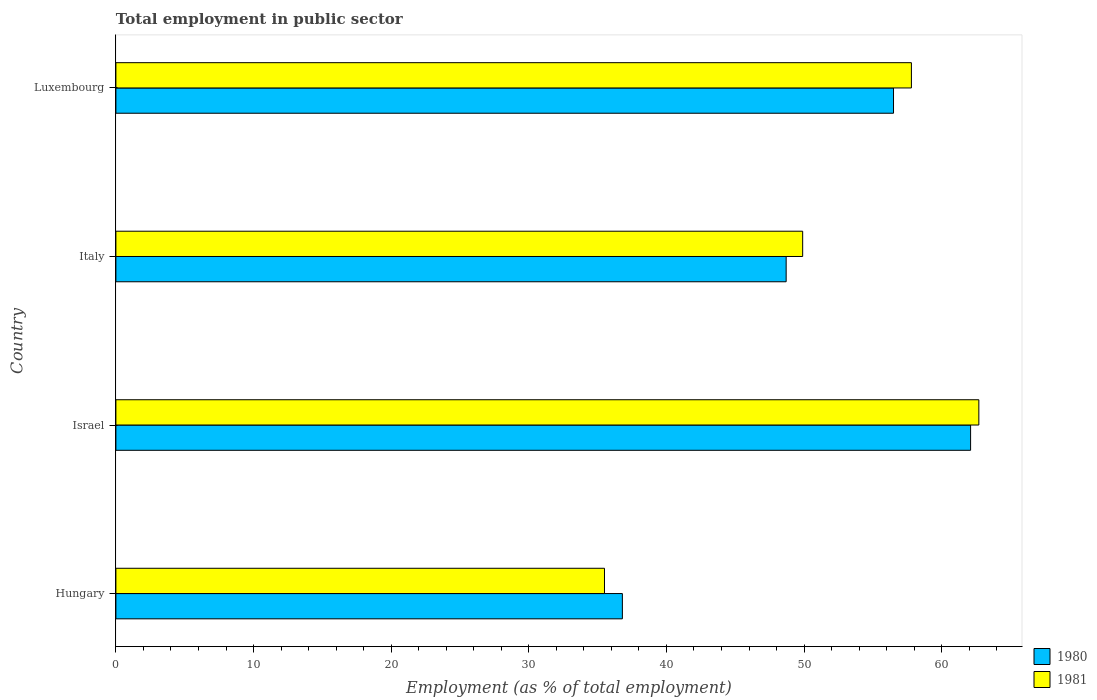How many groups of bars are there?
Provide a succinct answer. 4. Are the number of bars per tick equal to the number of legend labels?
Provide a succinct answer. Yes. Are the number of bars on each tick of the Y-axis equal?
Offer a very short reply. Yes. What is the label of the 3rd group of bars from the top?
Offer a terse response. Israel. In how many cases, is the number of bars for a given country not equal to the number of legend labels?
Your response must be concise. 0. What is the employment in public sector in 1980 in Israel?
Keep it short and to the point. 62.1. Across all countries, what is the maximum employment in public sector in 1981?
Provide a short and direct response. 62.7. Across all countries, what is the minimum employment in public sector in 1980?
Your answer should be compact. 36.8. In which country was the employment in public sector in 1981 maximum?
Your answer should be compact. Israel. In which country was the employment in public sector in 1981 minimum?
Your answer should be very brief. Hungary. What is the total employment in public sector in 1980 in the graph?
Provide a succinct answer. 204.1. What is the difference between the employment in public sector in 1981 in Hungary and that in Luxembourg?
Make the answer very short. -22.3. What is the difference between the employment in public sector in 1980 in Luxembourg and the employment in public sector in 1981 in Italy?
Provide a short and direct response. 6.6. What is the average employment in public sector in 1980 per country?
Your answer should be compact. 51.02. What is the difference between the employment in public sector in 1981 and employment in public sector in 1980 in Luxembourg?
Ensure brevity in your answer.  1.3. In how many countries, is the employment in public sector in 1980 greater than 22 %?
Offer a very short reply. 4. What is the ratio of the employment in public sector in 1980 in Hungary to that in Luxembourg?
Your answer should be very brief. 0.65. Is the employment in public sector in 1981 in Hungary less than that in Israel?
Give a very brief answer. Yes. What is the difference between the highest and the second highest employment in public sector in 1981?
Offer a very short reply. 4.9. What is the difference between the highest and the lowest employment in public sector in 1981?
Offer a terse response. 27.2. Are all the bars in the graph horizontal?
Your response must be concise. Yes. How many countries are there in the graph?
Provide a succinct answer. 4. Does the graph contain grids?
Your response must be concise. No. How many legend labels are there?
Provide a succinct answer. 2. How are the legend labels stacked?
Your answer should be very brief. Vertical. What is the title of the graph?
Your response must be concise. Total employment in public sector. What is the label or title of the X-axis?
Provide a short and direct response. Employment (as % of total employment). What is the label or title of the Y-axis?
Ensure brevity in your answer.  Country. What is the Employment (as % of total employment) of 1980 in Hungary?
Your response must be concise. 36.8. What is the Employment (as % of total employment) in 1981 in Hungary?
Provide a short and direct response. 35.5. What is the Employment (as % of total employment) in 1980 in Israel?
Keep it short and to the point. 62.1. What is the Employment (as % of total employment) in 1981 in Israel?
Keep it short and to the point. 62.7. What is the Employment (as % of total employment) of 1980 in Italy?
Your answer should be very brief. 48.7. What is the Employment (as % of total employment) of 1981 in Italy?
Provide a short and direct response. 49.9. What is the Employment (as % of total employment) of 1980 in Luxembourg?
Ensure brevity in your answer.  56.5. What is the Employment (as % of total employment) in 1981 in Luxembourg?
Ensure brevity in your answer.  57.8. Across all countries, what is the maximum Employment (as % of total employment) in 1980?
Make the answer very short. 62.1. Across all countries, what is the maximum Employment (as % of total employment) in 1981?
Offer a very short reply. 62.7. Across all countries, what is the minimum Employment (as % of total employment) of 1980?
Keep it short and to the point. 36.8. Across all countries, what is the minimum Employment (as % of total employment) in 1981?
Your answer should be compact. 35.5. What is the total Employment (as % of total employment) of 1980 in the graph?
Make the answer very short. 204.1. What is the total Employment (as % of total employment) of 1981 in the graph?
Keep it short and to the point. 205.9. What is the difference between the Employment (as % of total employment) of 1980 in Hungary and that in Israel?
Your response must be concise. -25.3. What is the difference between the Employment (as % of total employment) in 1981 in Hungary and that in Israel?
Offer a terse response. -27.2. What is the difference between the Employment (as % of total employment) in 1980 in Hungary and that in Italy?
Provide a succinct answer. -11.9. What is the difference between the Employment (as % of total employment) in 1981 in Hungary and that in Italy?
Your answer should be compact. -14.4. What is the difference between the Employment (as % of total employment) in 1980 in Hungary and that in Luxembourg?
Keep it short and to the point. -19.7. What is the difference between the Employment (as % of total employment) in 1981 in Hungary and that in Luxembourg?
Provide a succinct answer. -22.3. What is the difference between the Employment (as % of total employment) of 1980 in Israel and that in Italy?
Provide a succinct answer. 13.4. What is the difference between the Employment (as % of total employment) in 1980 in Italy and that in Luxembourg?
Offer a very short reply. -7.8. What is the difference between the Employment (as % of total employment) of 1981 in Italy and that in Luxembourg?
Provide a succinct answer. -7.9. What is the difference between the Employment (as % of total employment) in 1980 in Hungary and the Employment (as % of total employment) in 1981 in Israel?
Make the answer very short. -25.9. What is the difference between the Employment (as % of total employment) of 1980 in Hungary and the Employment (as % of total employment) of 1981 in Italy?
Provide a succinct answer. -13.1. What is the difference between the Employment (as % of total employment) of 1980 in Hungary and the Employment (as % of total employment) of 1981 in Luxembourg?
Make the answer very short. -21. What is the difference between the Employment (as % of total employment) of 1980 in Israel and the Employment (as % of total employment) of 1981 in Italy?
Offer a very short reply. 12.2. What is the difference between the Employment (as % of total employment) of 1980 in Israel and the Employment (as % of total employment) of 1981 in Luxembourg?
Provide a short and direct response. 4.3. What is the average Employment (as % of total employment) in 1980 per country?
Offer a terse response. 51.02. What is the average Employment (as % of total employment) in 1981 per country?
Provide a short and direct response. 51.48. What is the difference between the Employment (as % of total employment) in 1980 and Employment (as % of total employment) in 1981 in Israel?
Offer a very short reply. -0.6. What is the difference between the Employment (as % of total employment) of 1980 and Employment (as % of total employment) of 1981 in Italy?
Offer a terse response. -1.2. What is the ratio of the Employment (as % of total employment) in 1980 in Hungary to that in Israel?
Your answer should be compact. 0.59. What is the ratio of the Employment (as % of total employment) in 1981 in Hungary to that in Israel?
Your response must be concise. 0.57. What is the ratio of the Employment (as % of total employment) in 1980 in Hungary to that in Italy?
Your answer should be compact. 0.76. What is the ratio of the Employment (as % of total employment) in 1981 in Hungary to that in Italy?
Your answer should be compact. 0.71. What is the ratio of the Employment (as % of total employment) in 1980 in Hungary to that in Luxembourg?
Provide a succinct answer. 0.65. What is the ratio of the Employment (as % of total employment) in 1981 in Hungary to that in Luxembourg?
Your answer should be very brief. 0.61. What is the ratio of the Employment (as % of total employment) in 1980 in Israel to that in Italy?
Your response must be concise. 1.28. What is the ratio of the Employment (as % of total employment) of 1981 in Israel to that in Italy?
Offer a terse response. 1.26. What is the ratio of the Employment (as % of total employment) of 1980 in Israel to that in Luxembourg?
Provide a short and direct response. 1.1. What is the ratio of the Employment (as % of total employment) in 1981 in Israel to that in Luxembourg?
Keep it short and to the point. 1.08. What is the ratio of the Employment (as % of total employment) in 1980 in Italy to that in Luxembourg?
Give a very brief answer. 0.86. What is the ratio of the Employment (as % of total employment) of 1981 in Italy to that in Luxembourg?
Give a very brief answer. 0.86. What is the difference between the highest and the second highest Employment (as % of total employment) in 1980?
Give a very brief answer. 5.6. What is the difference between the highest and the second highest Employment (as % of total employment) of 1981?
Offer a terse response. 4.9. What is the difference between the highest and the lowest Employment (as % of total employment) in 1980?
Make the answer very short. 25.3. What is the difference between the highest and the lowest Employment (as % of total employment) of 1981?
Make the answer very short. 27.2. 